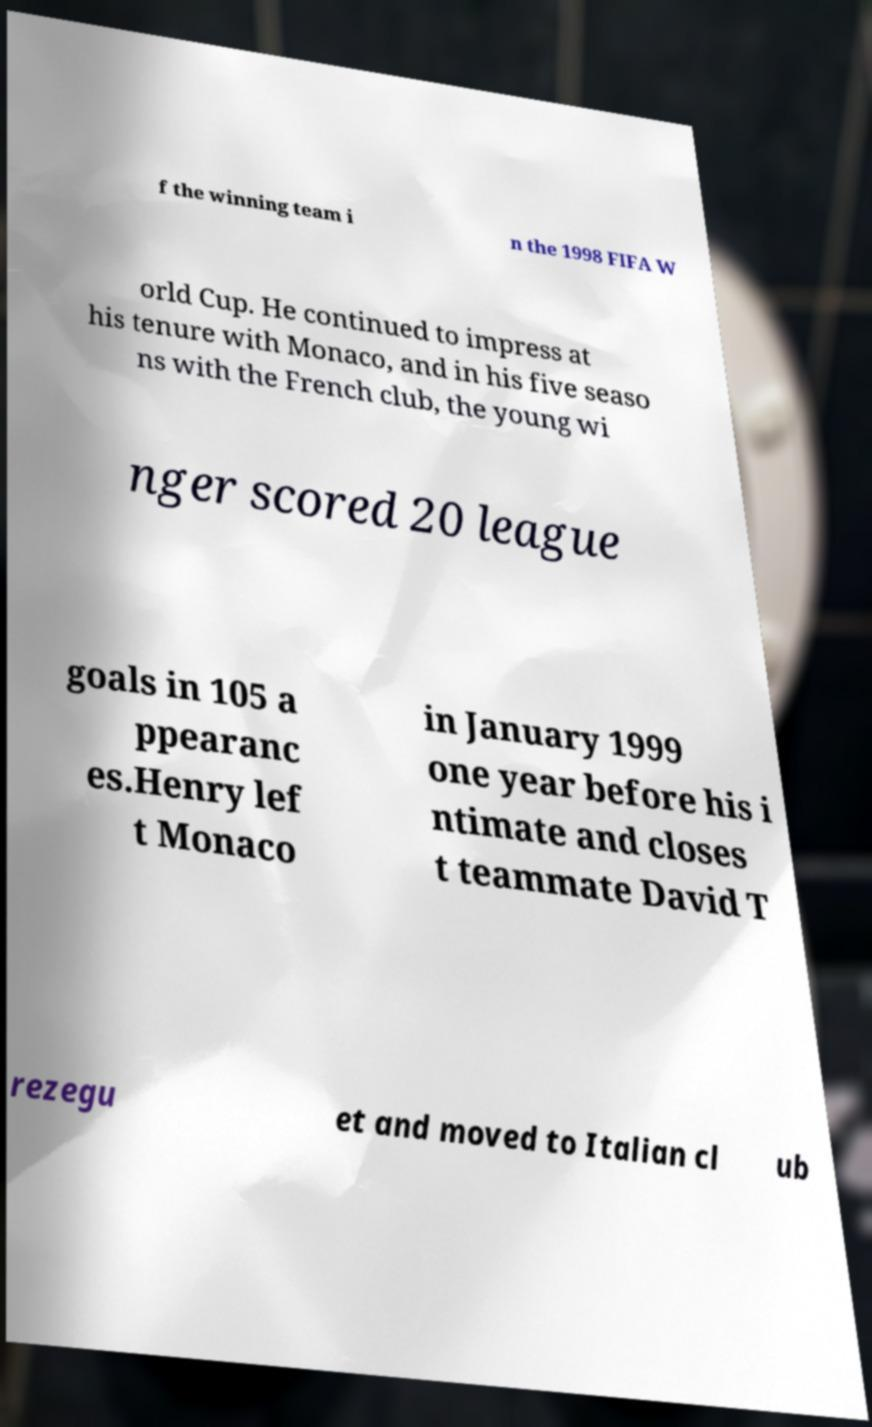Please identify and transcribe the text found in this image. f the winning team i n the 1998 FIFA W orld Cup. He continued to impress at his tenure with Monaco, and in his five seaso ns with the French club, the young wi nger scored 20 league goals in 105 a ppearanc es.Henry lef t Monaco in January 1999 one year before his i ntimate and closes t teammate David T rezegu et and moved to Italian cl ub 